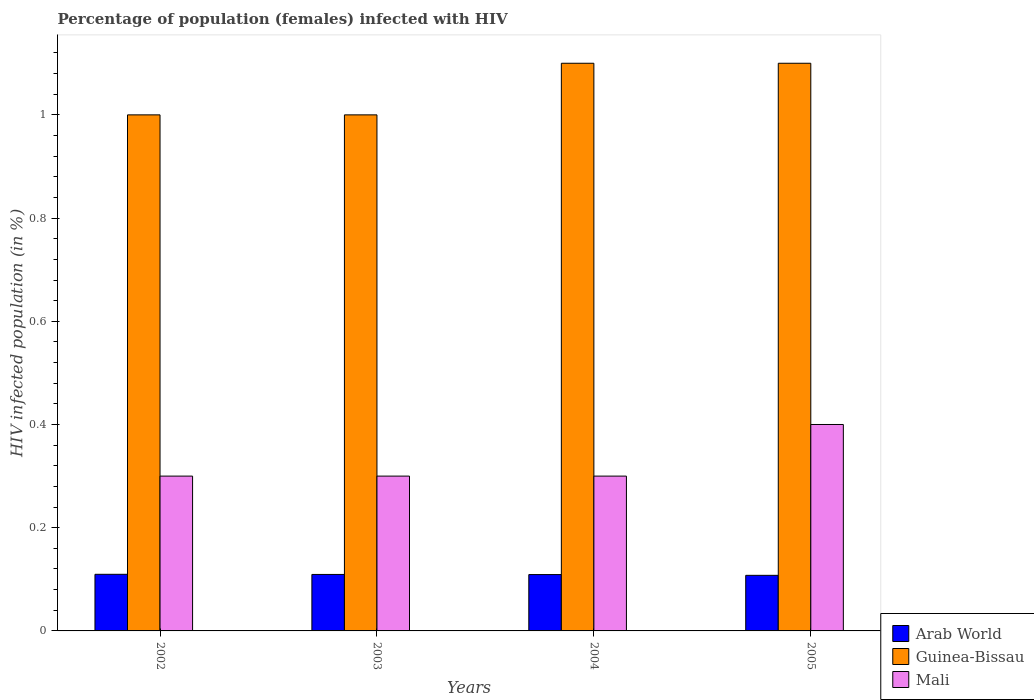How many different coloured bars are there?
Keep it short and to the point. 3. Are the number of bars per tick equal to the number of legend labels?
Provide a short and direct response. Yes. How many bars are there on the 4th tick from the left?
Offer a very short reply. 3. How many bars are there on the 4th tick from the right?
Offer a very short reply. 3. Across all years, what is the minimum percentage of HIV infected female population in Guinea-Bissau?
Provide a succinct answer. 1. What is the total percentage of HIV infected female population in Mali in the graph?
Ensure brevity in your answer.  1.3. What is the difference between the percentage of HIV infected female population in Mali in 2002 and that in 2003?
Ensure brevity in your answer.  0. What is the difference between the percentage of HIV infected female population in Arab World in 2002 and the percentage of HIV infected female population in Guinea-Bissau in 2004?
Your answer should be compact. -0.99. What is the average percentage of HIV infected female population in Guinea-Bissau per year?
Offer a terse response. 1.05. In the year 2005, what is the difference between the percentage of HIV infected female population in Arab World and percentage of HIV infected female population in Guinea-Bissau?
Your response must be concise. -0.99. What is the ratio of the percentage of HIV infected female population in Arab World in 2002 to that in 2003?
Your answer should be very brief. 1. What is the difference between the highest and the second highest percentage of HIV infected female population in Mali?
Your answer should be very brief. 0.1. What is the difference between the highest and the lowest percentage of HIV infected female population in Mali?
Offer a terse response. 0.1. In how many years, is the percentage of HIV infected female population in Arab World greater than the average percentage of HIV infected female population in Arab World taken over all years?
Provide a short and direct response. 3. What does the 1st bar from the left in 2003 represents?
Keep it short and to the point. Arab World. What does the 2nd bar from the right in 2004 represents?
Offer a terse response. Guinea-Bissau. Is it the case that in every year, the sum of the percentage of HIV infected female population in Guinea-Bissau and percentage of HIV infected female population in Arab World is greater than the percentage of HIV infected female population in Mali?
Ensure brevity in your answer.  Yes. Does the graph contain any zero values?
Your answer should be very brief. No. Where does the legend appear in the graph?
Ensure brevity in your answer.  Bottom right. How are the legend labels stacked?
Provide a short and direct response. Vertical. What is the title of the graph?
Offer a terse response. Percentage of population (females) infected with HIV. What is the label or title of the X-axis?
Offer a very short reply. Years. What is the label or title of the Y-axis?
Keep it short and to the point. HIV infected population (in %). What is the HIV infected population (in %) of Arab World in 2002?
Your answer should be very brief. 0.11. What is the HIV infected population (in %) of Guinea-Bissau in 2002?
Ensure brevity in your answer.  1. What is the HIV infected population (in %) of Mali in 2002?
Your answer should be compact. 0.3. What is the HIV infected population (in %) of Arab World in 2003?
Your answer should be compact. 0.11. What is the HIV infected population (in %) of Mali in 2003?
Provide a short and direct response. 0.3. What is the HIV infected population (in %) in Arab World in 2004?
Make the answer very short. 0.11. What is the HIV infected population (in %) of Guinea-Bissau in 2004?
Your response must be concise. 1.1. What is the HIV infected population (in %) in Arab World in 2005?
Offer a terse response. 0.11. What is the HIV infected population (in %) in Mali in 2005?
Your response must be concise. 0.4. Across all years, what is the maximum HIV infected population (in %) in Arab World?
Give a very brief answer. 0.11. Across all years, what is the maximum HIV infected population (in %) in Guinea-Bissau?
Provide a short and direct response. 1.1. Across all years, what is the maximum HIV infected population (in %) in Mali?
Make the answer very short. 0.4. Across all years, what is the minimum HIV infected population (in %) of Arab World?
Your answer should be very brief. 0.11. What is the total HIV infected population (in %) of Arab World in the graph?
Offer a very short reply. 0.44. What is the total HIV infected population (in %) in Mali in the graph?
Your response must be concise. 1.3. What is the difference between the HIV infected population (in %) of Arab World in 2002 and that in 2003?
Your answer should be very brief. 0. What is the difference between the HIV infected population (in %) of Guinea-Bissau in 2002 and that in 2003?
Keep it short and to the point. 0. What is the difference between the HIV infected population (in %) in Mali in 2002 and that in 2003?
Offer a very short reply. 0. What is the difference between the HIV infected population (in %) of Arab World in 2002 and that in 2004?
Make the answer very short. 0. What is the difference between the HIV infected population (in %) of Mali in 2002 and that in 2004?
Provide a succinct answer. 0. What is the difference between the HIV infected population (in %) of Arab World in 2002 and that in 2005?
Your response must be concise. 0. What is the difference between the HIV infected population (in %) in Guinea-Bissau in 2002 and that in 2005?
Provide a short and direct response. -0.1. What is the difference between the HIV infected population (in %) in Mali in 2002 and that in 2005?
Offer a very short reply. -0.1. What is the difference between the HIV infected population (in %) in Arab World in 2003 and that in 2005?
Give a very brief answer. 0. What is the difference between the HIV infected population (in %) in Guinea-Bissau in 2003 and that in 2005?
Offer a terse response. -0.1. What is the difference between the HIV infected population (in %) in Arab World in 2004 and that in 2005?
Ensure brevity in your answer.  0. What is the difference between the HIV infected population (in %) of Mali in 2004 and that in 2005?
Your answer should be compact. -0.1. What is the difference between the HIV infected population (in %) of Arab World in 2002 and the HIV infected population (in %) of Guinea-Bissau in 2003?
Make the answer very short. -0.89. What is the difference between the HIV infected population (in %) of Arab World in 2002 and the HIV infected population (in %) of Mali in 2003?
Your response must be concise. -0.19. What is the difference between the HIV infected population (in %) of Arab World in 2002 and the HIV infected population (in %) of Guinea-Bissau in 2004?
Your answer should be very brief. -0.99. What is the difference between the HIV infected population (in %) in Arab World in 2002 and the HIV infected population (in %) in Mali in 2004?
Offer a terse response. -0.19. What is the difference between the HIV infected population (in %) in Guinea-Bissau in 2002 and the HIV infected population (in %) in Mali in 2004?
Offer a terse response. 0.7. What is the difference between the HIV infected population (in %) in Arab World in 2002 and the HIV infected population (in %) in Guinea-Bissau in 2005?
Offer a very short reply. -0.99. What is the difference between the HIV infected population (in %) in Arab World in 2002 and the HIV infected population (in %) in Mali in 2005?
Your answer should be compact. -0.29. What is the difference between the HIV infected population (in %) in Arab World in 2003 and the HIV infected population (in %) in Guinea-Bissau in 2004?
Offer a terse response. -0.99. What is the difference between the HIV infected population (in %) in Arab World in 2003 and the HIV infected population (in %) in Mali in 2004?
Your response must be concise. -0.19. What is the difference between the HIV infected population (in %) of Arab World in 2003 and the HIV infected population (in %) of Guinea-Bissau in 2005?
Offer a very short reply. -0.99. What is the difference between the HIV infected population (in %) of Arab World in 2003 and the HIV infected population (in %) of Mali in 2005?
Offer a very short reply. -0.29. What is the difference between the HIV infected population (in %) in Guinea-Bissau in 2003 and the HIV infected population (in %) in Mali in 2005?
Your response must be concise. 0.6. What is the difference between the HIV infected population (in %) of Arab World in 2004 and the HIV infected population (in %) of Guinea-Bissau in 2005?
Make the answer very short. -0.99. What is the difference between the HIV infected population (in %) in Arab World in 2004 and the HIV infected population (in %) in Mali in 2005?
Your response must be concise. -0.29. What is the average HIV infected population (in %) of Arab World per year?
Your answer should be compact. 0.11. What is the average HIV infected population (in %) in Guinea-Bissau per year?
Your answer should be very brief. 1.05. What is the average HIV infected population (in %) of Mali per year?
Your answer should be compact. 0.33. In the year 2002, what is the difference between the HIV infected population (in %) of Arab World and HIV infected population (in %) of Guinea-Bissau?
Your response must be concise. -0.89. In the year 2002, what is the difference between the HIV infected population (in %) of Arab World and HIV infected population (in %) of Mali?
Your answer should be very brief. -0.19. In the year 2002, what is the difference between the HIV infected population (in %) in Guinea-Bissau and HIV infected population (in %) in Mali?
Provide a short and direct response. 0.7. In the year 2003, what is the difference between the HIV infected population (in %) in Arab World and HIV infected population (in %) in Guinea-Bissau?
Provide a succinct answer. -0.89. In the year 2003, what is the difference between the HIV infected population (in %) of Arab World and HIV infected population (in %) of Mali?
Keep it short and to the point. -0.19. In the year 2003, what is the difference between the HIV infected population (in %) in Guinea-Bissau and HIV infected population (in %) in Mali?
Give a very brief answer. 0.7. In the year 2004, what is the difference between the HIV infected population (in %) in Arab World and HIV infected population (in %) in Guinea-Bissau?
Your answer should be very brief. -0.99. In the year 2004, what is the difference between the HIV infected population (in %) in Arab World and HIV infected population (in %) in Mali?
Your answer should be very brief. -0.19. In the year 2004, what is the difference between the HIV infected population (in %) of Guinea-Bissau and HIV infected population (in %) of Mali?
Make the answer very short. 0.8. In the year 2005, what is the difference between the HIV infected population (in %) of Arab World and HIV infected population (in %) of Guinea-Bissau?
Provide a short and direct response. -0.99. In the year 2005, what is the difference between the HIV infected population (in %) in Arab World and HIV infected population (in %) in Mali?
Keep it short and to the point. -0.29. In the year 2005, what is the difference between the HIV infected population (in %) in Guinea-Bissau and HIV infected population (in %) in Mali?
Provide a short and direct response. 0.7. What is the ratio of the HIV infected population (in %) in Guinea-Bissau in 2002 to that in 2003?
Offer a terse response. 1. What is the ratio of the HIV infected population (in %) of Mali in 2002 to that in 2003?
Your answer should be compact. 1. What is the ratio of the HIV infected population (in %) in Arab World in 2002 to that in 2004?
Make the answer very short. 1. What is the ratio of the HIV infected population (in %) in Arab World in 2002 to that in 2005?
Your response must be concise. 1.02. What is the ratio of the HIV infected population (in %) of Guinea-Bissau in 2002 to that in 2005?
Your response must be concise. 0.91. What is the ratio of the HIV infected population (in %) in Arab World in 2003 to that in 2004?
Offer a very short reply. 1. What is the ratio of the HIV infected population (in %) of Guinea-Bissau in 2003 to that in 2004?
Ensure brevity in your answer.  0.91. What is the ratio of the HIV infected population (in %) of Arab World in 2003 to that in 2005?
Offer a very short reply. 1.02. What is the ratio of the HIV infected population (in %) of Guinea-Bissau in 2003 to that in 2005?
Your answer should be very brief. 0.91. What is the ratio of the HIV infected population (in %) of Mali in 2003 to that in 2005?
Offer a very short reply. 0.75. What is the ratio of the HIV infected population (in %) of Arab World in 2004 to that in 2005?
Your answer should be very brief. 1.01. What is the ratio of the HIV infected population (in %) in Guinea-Bissau in 2004 to that in 2005?
Offer a terse response. 1. What is the ratio of the HIV infected population (in %) in Mali in 2004 to that in 2005?
Your answer should be very brief. 0.75. What is the difference between the highest and the second highest HIV infected population (in %) of Mali?
Ensure brevity in your answer.  0.1. What is the difference between the highest and the lowest HIV infected population (in %) of Arab World?
Your answer should be very brief. 0. What is the difference between the highest and the lowest HIV infected population (in %) in Mali?
Make the answer very short. 0.1. 